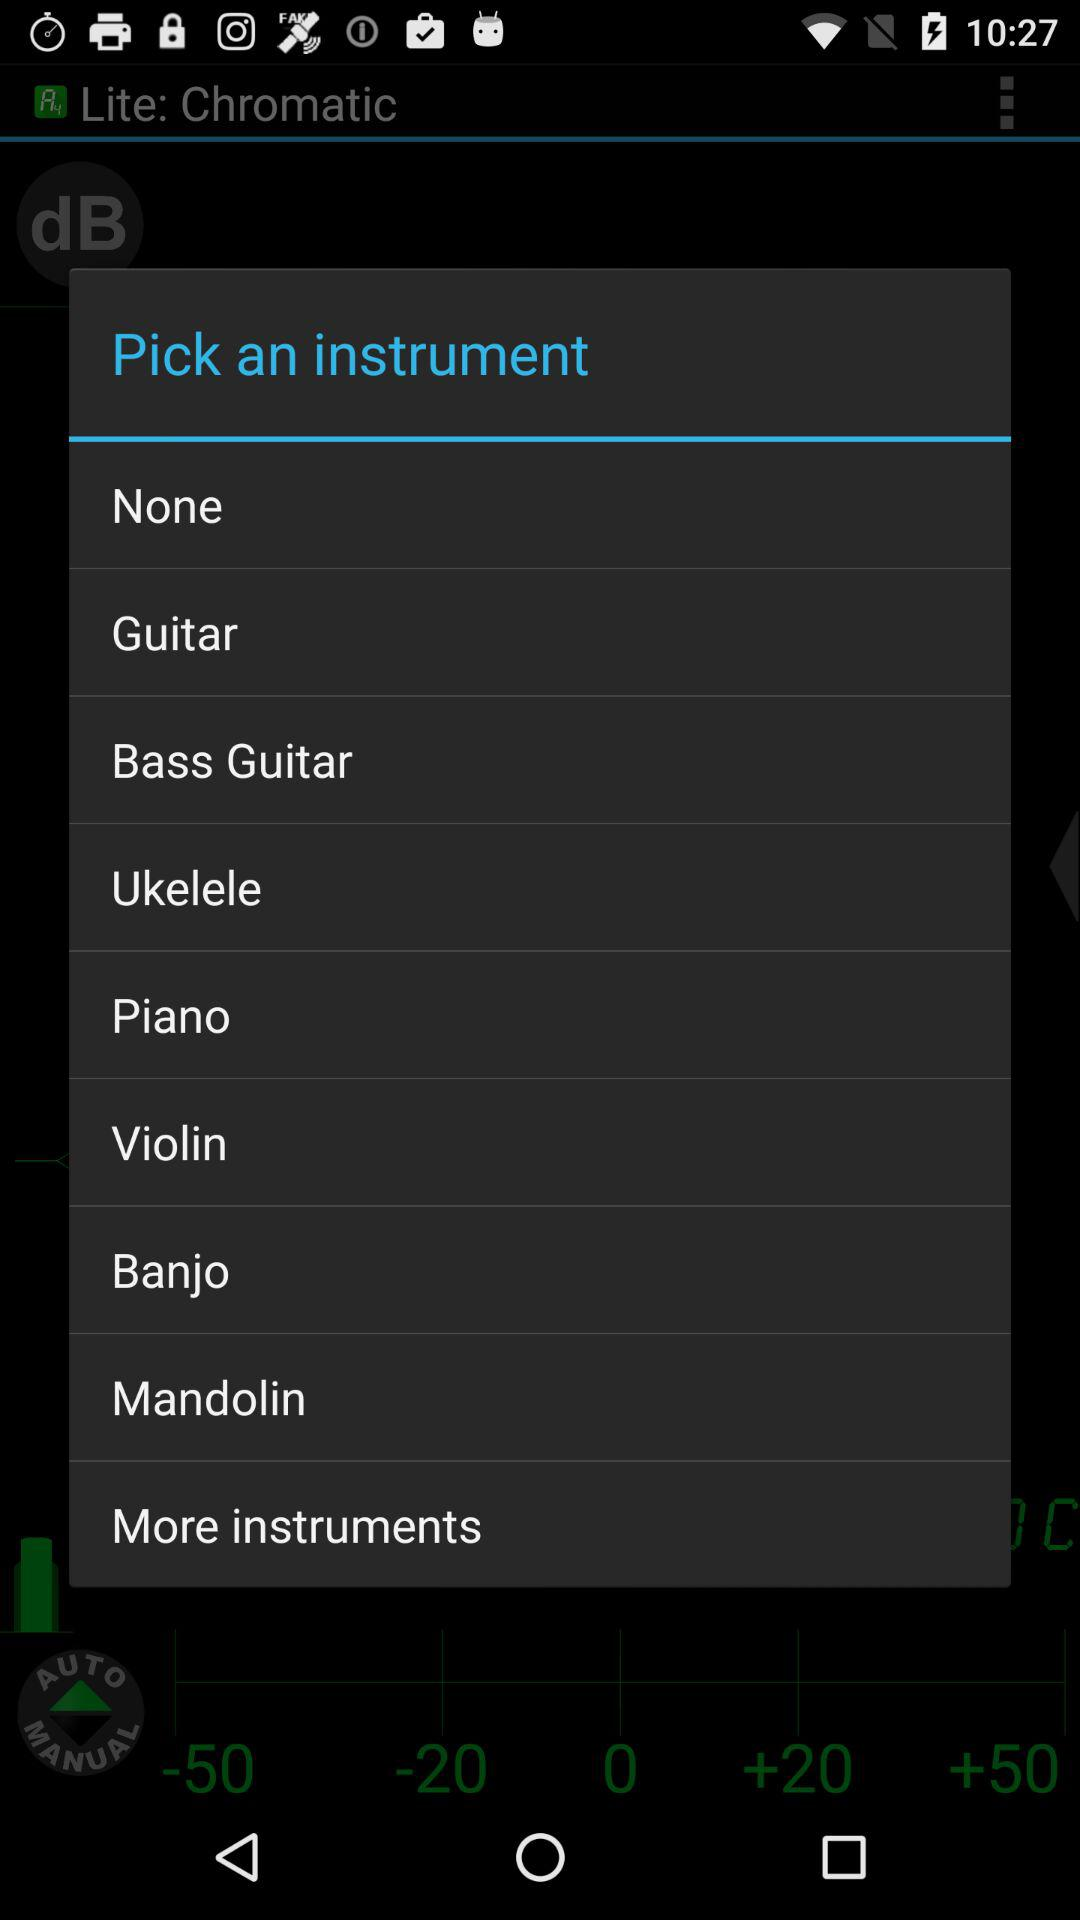How much does the lite application cost?
When the provided information is insufficient, respond with <no answer>. <no answer> 